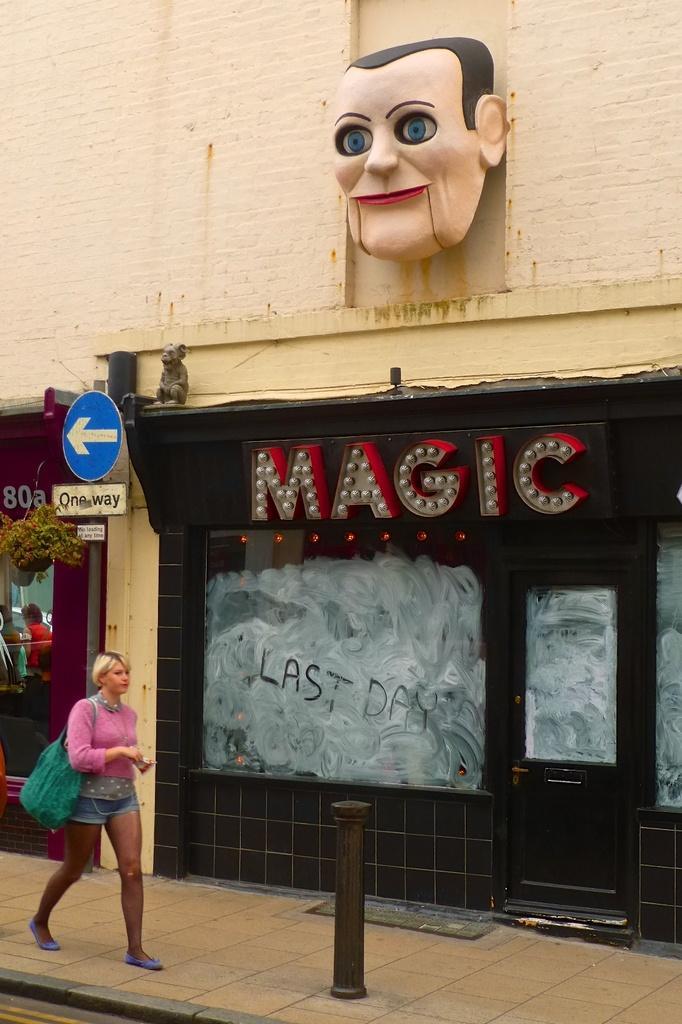Please provide a concise description of this image. In this image there is a girl walking on the footpath. Beside her there is a store on which there is some led hoarding. At the top there is a statue of a face. 